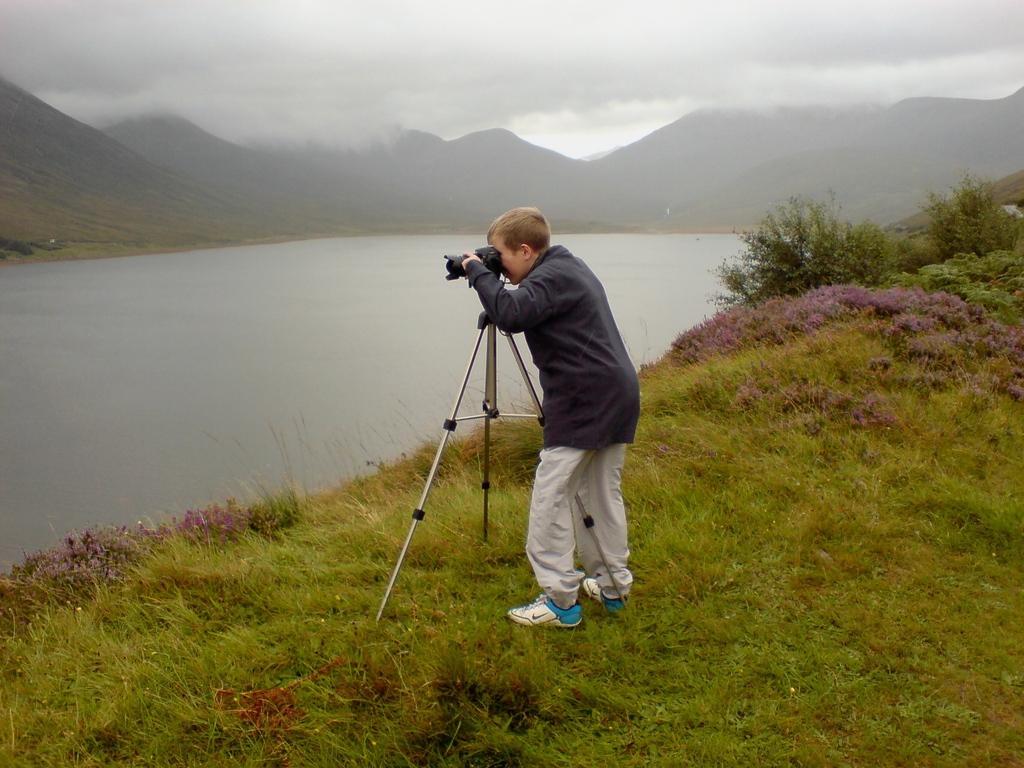How would you summarize this image in a sentence or two? In this image there is a boy standing on the ground. In front of him there is a tripod stand. On the tripod stand there is a camera. He is looking at the camera. There are plants and grass on the ground. To the left there is water. In the background there are mountains. At the top there is the sky. There is fog in the image. 